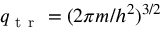<formula> <loc_0><loc_0><loc_500><loc_500>q _ { t r } = ( 2 \pi m / h ^ { 2 } ) ^ { 3 / 2 }</formula> 